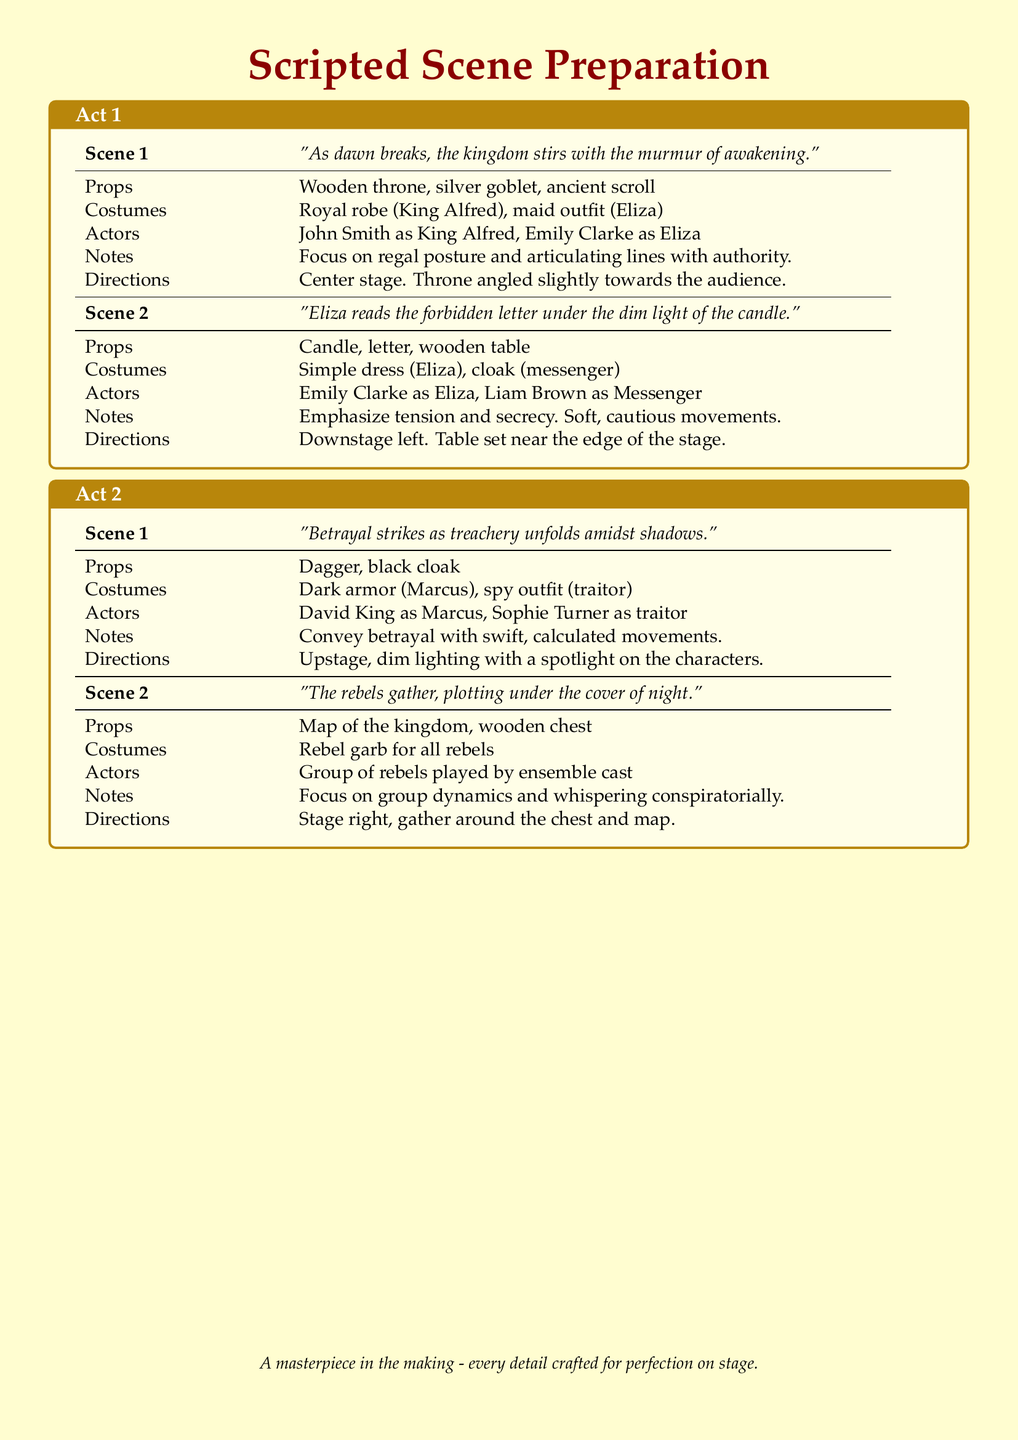What is the name of the King in Act 1? The document lists John Smith as playing King Alfred, providing the character's name in the casting information.
Answer: King Alfred What does Eliza read in Scene 2 of Act 1? The script indicates that Eliza reads a forbidden letter, as mentioned in the scene description.
Answer: Forbidden letter Which actor plays the role of Marcus in Act 2? David King is assigned the role of Marcus, as per the actor list in the document.
Answer: David King How many scenes are in Act 2? The document outlines two scenes in Act 2, as highlighted in the structure of the acts.
Answer: 2 What props are needed for Scene 1 of Act 2? The props listed for Scene 1 of Act 2 include a dagger and a black cloak, specified under the props section for that scene.
Answer: Dagger, black cloak Where is Scene 2 of Act 1 set on stage? The directions indicate that Scene 2 of Act 1 is set downstage left, detailing the specific position for the performance.
Answer: Downstage left What costume does Eliza wear in Scene 1 of Act 1? The costume listed for Eliza in Scene 1 of Act 1 is a maid outfit, providing specific costume details for the character.
Answer: Maid outfit What is the main theme of Scene 1 in Act 2? The theme described is betrayal, as indicated in the opening line of the scene description.
Answer: Betrayal Who are the actors in Scene 1 of Act 1? The actors assigned are John Smith as King Alfred and Emily Clarke as Eliza, as detailed in the cast information for the scene.
Answer: John Smith, Emily Clarke 